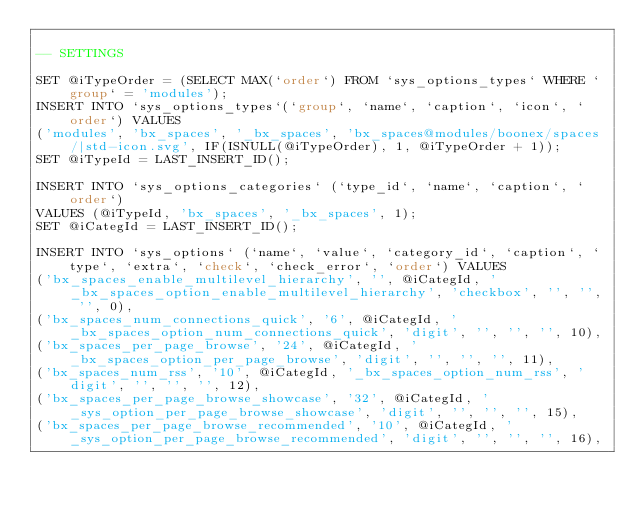Convert code to text. <code><loc_0><loc_0><loc_500><loc_500><_SQL_>
-- SETTINGS

SET @iTypeOrder = (SELECT MAX(`order`) FROM `sys_options_types` WHERE `group` = 'modules');
INSERT INTO `sys_options_types`(`group`, `name`, `caption`, `icon`, `order`) VALUES 
('modules', 'bx_spaces', '_bx_spaces', 'bx_spaces@modules/boonex/spaces/|std-icon.svg', IF(ISNULL(@iTypeOrder), 1, @iTypeOrder + 1));
SET @iTypeId = LAST_INSERT_ID();

INSERT INTO `sys_options_categories` (`type_id`, `name`, `caption`, `order`)
VALUES (@iTypeId, 'bx_spaces', '_bx_spaces', 1);
SET @iCategId = LAST_INSERT_ID();

INSERT INTO `sys_options` (`name`, `value`, `category_id`, `caption`, `type`, `extra`, `check`, `check_error`, `order`) VALUES
('bx_spaces_enable_multilevel_hierarchy', '', @iCategId, '_bx_spaces_option_enable_multilevel_hierarchy', 'checkbox', '', '', '', 0),
('bx_spaces_num_connections_quick', '6', @iCategId, '_bx_spaces_option_num_connections_quick', 'digit', '', '', '', 10),
('bx_spaces_per_page_browse', '24', @iCategId, '_bx_spaces_option_per_page_browse', 'digit', '', '', '', 11),
('bx_spaces_num_rss', '10', @iCategId, '_bx_spaces_option_num_rss', 'digit', '', '', '', 12),
('bx_spaces_per_page_browse_showcase', '32', @iCategId, '_sys_option_per_page_browse_showcase', 'digit', '', '', '', 15),
('bx_spaces_per_page_browse_recommended', '10', @iCategId, '_sys_option_per_page_browse_recommended', 'digit', '', '', '', 16),</code> 